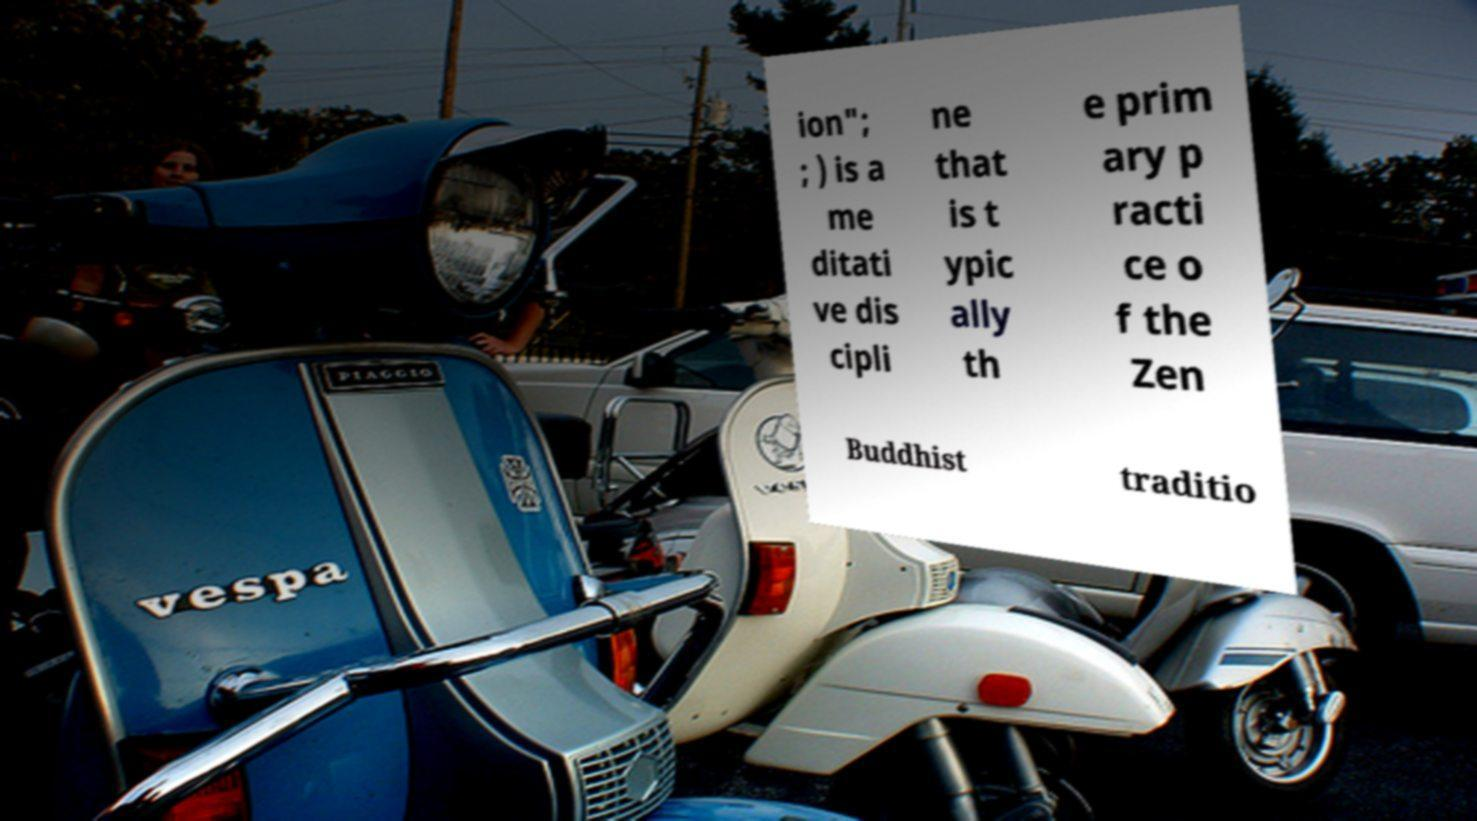Could you extract and type out the text from this image? ion"; ; ) is a me ditati ve dis cipli ne that is t ypic ally th e prim ary p racti ce o f the Zen Buddhist traditio 